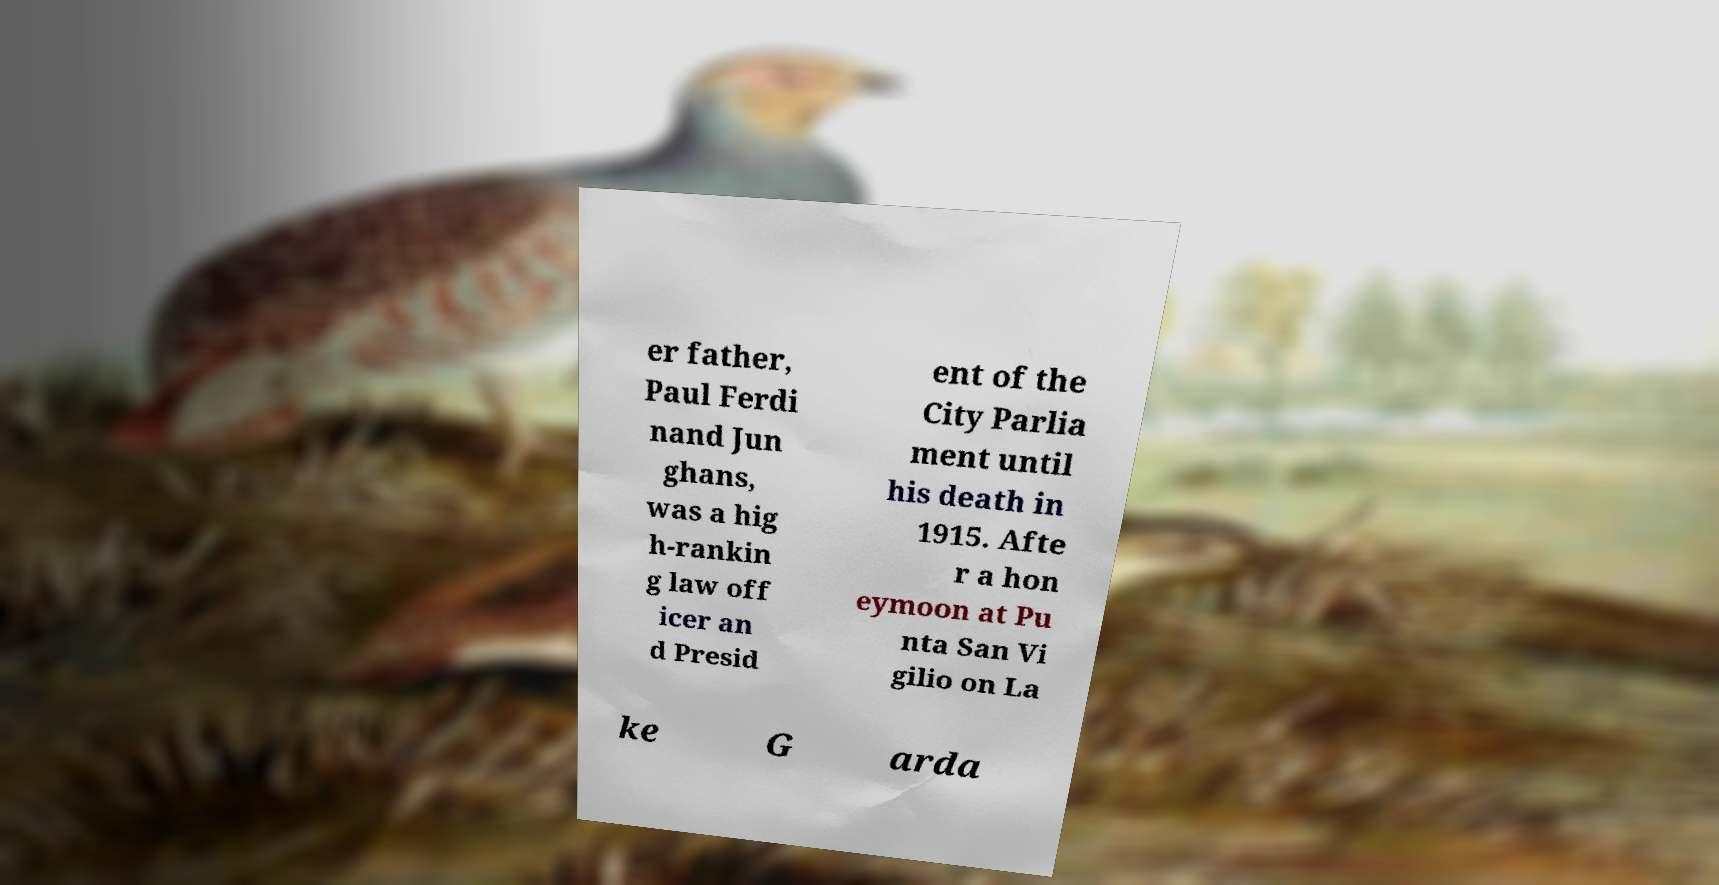Can you read and provide the text displayed in the image?This photo seems to have some interesting text. Can you extract and type it out for me? er father, Paul Ferdi nand Jun ghans, was a hig h-rankin g law off icer an d Presid ent of the City Parlia ment until his death in 1915. Afte r a hon eymoon at Pu nta San Vi gilio on La ke G arda 